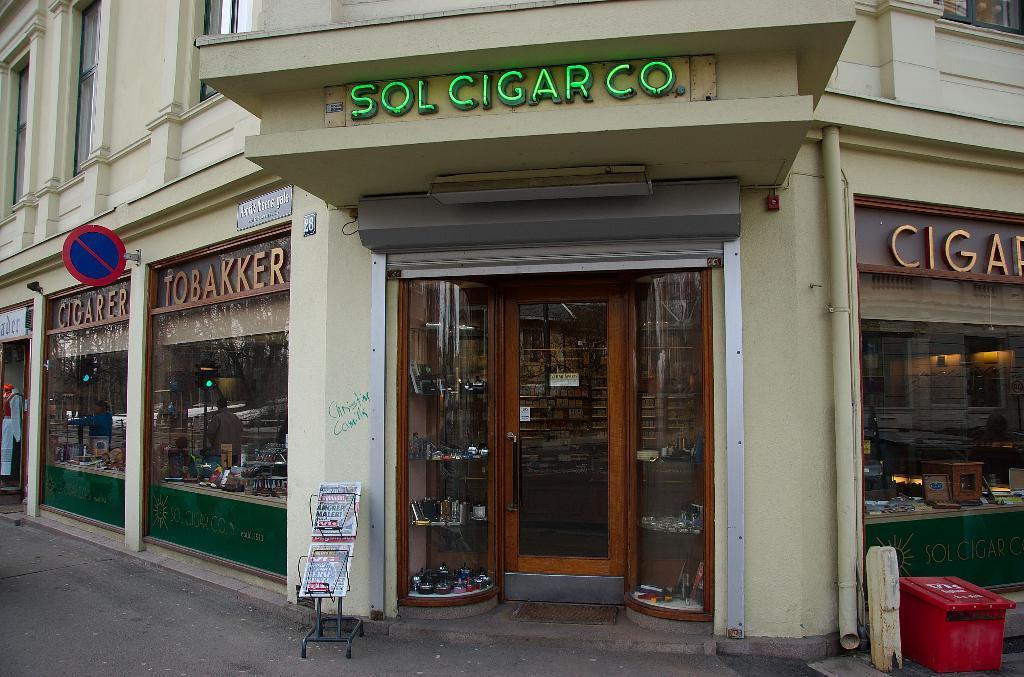How would you summarize this image in a sentence or two? In this picture I can see a building and I see a store and I see the boards on which there are words written and I see the path in front. On the right side of this image I see a red color container. 